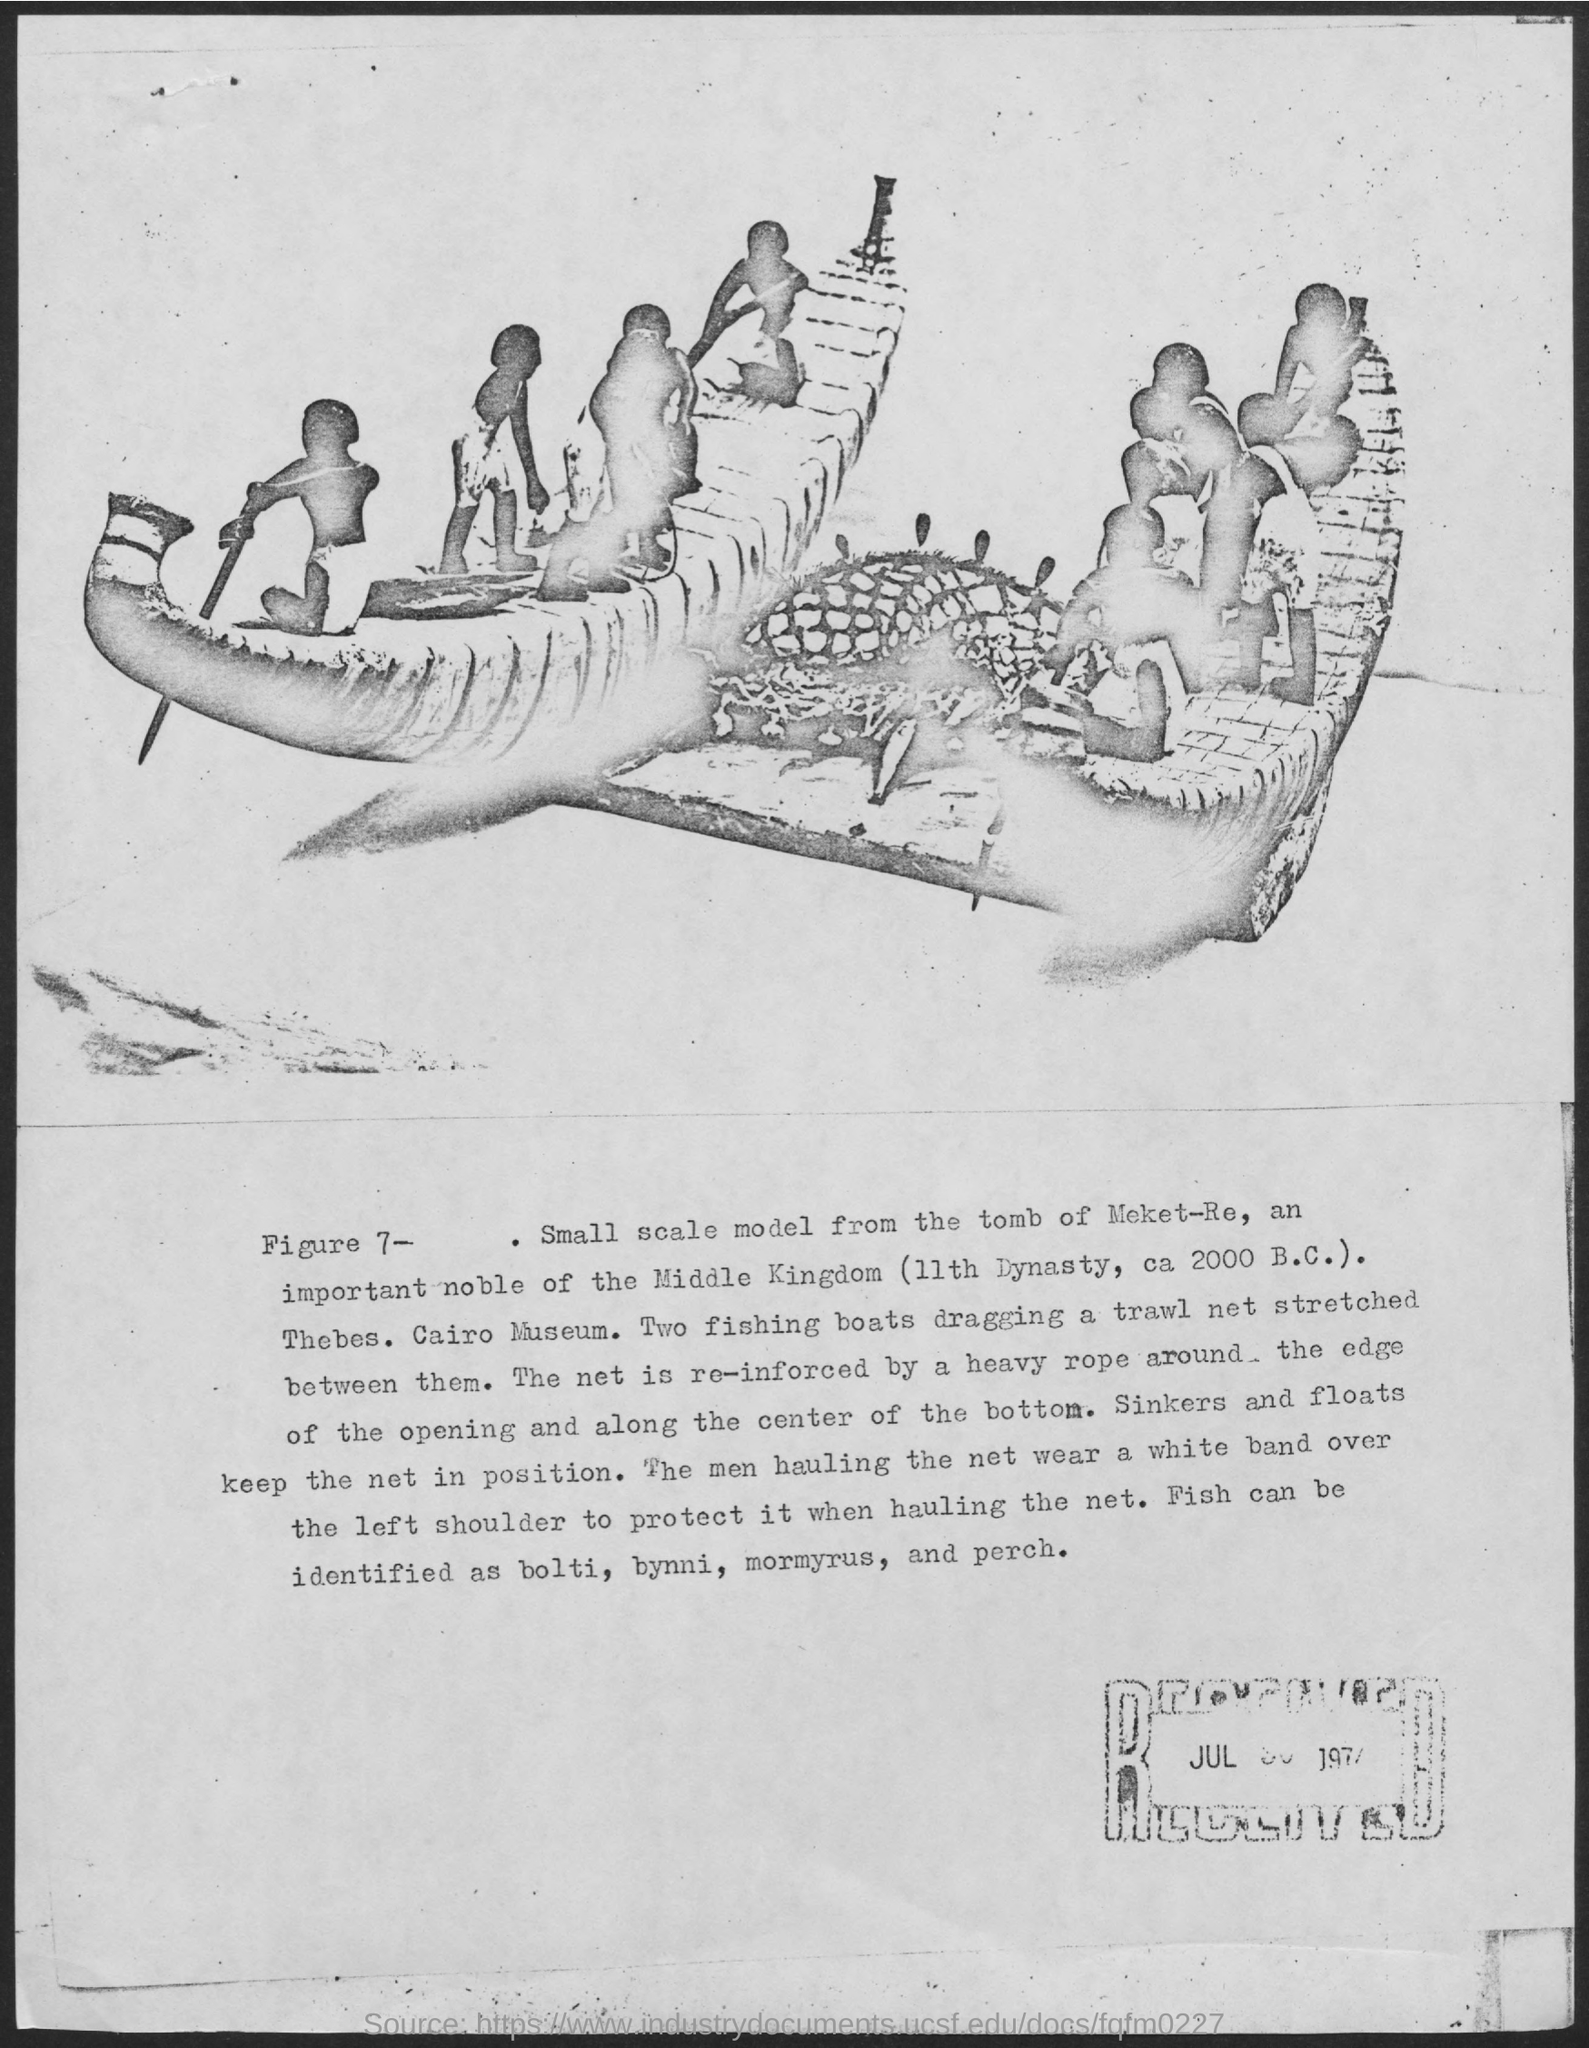Can you describe the techniques used in making this model? The model-making technique evident in the image would have required skilled artisans adept in woodwork and carving. They carefully crafted the shape of the boats and figures, ensuring a high level of detail right down to the net structures and the ropes. The positioning of the figures indicates a dynamic scene, showing movement and a snapshot of an everyday activity, which helps historians understand how these people interacted with their environment. 